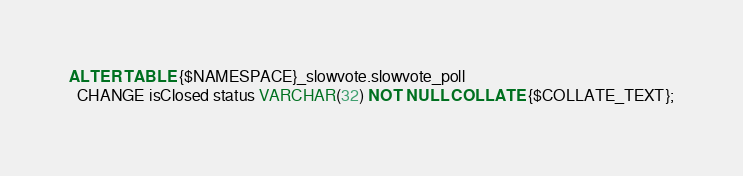<code> <loc_0><loc_0><loc_500><loc_500><_SQL_>ALTER TABLE {$NAMESPACE}_slowvote.slowvote_poll
  CHANGE isClosed status VARCHAR(32) NOT NULL COLLATE {$COLLATE_TEXT};
</code> 